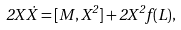Convert formula to latex. <formula><loc_0><loc_0><loc_500><loc_500>2 X \dot { X } = [ M , X ^ { 2 } ] + 2 X ^ { 2 } f ( L ) ,</formula> 